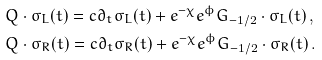<formula> <loc_0><loc_0><loc_500><loc_500>& Q \cdot \sigma _ { L } ( t ) = c \partial _ { t } \sigma _ { L } ( t ) + e ^ { - \chi } e ^ { \phi } G _ { - 1 / 2 } \cdot \sigma _ { L } ( t ) \, , \\ & Q \cdot \sigma _ { R } ( t ) = c \partial _ { t } \sigma _ { R } ( t ) + e ^ { - \chi } e ^ { \phi } G _ { - 1 / 2 } \cdot \sigma _ { R } ( t ) \, .</formula> 